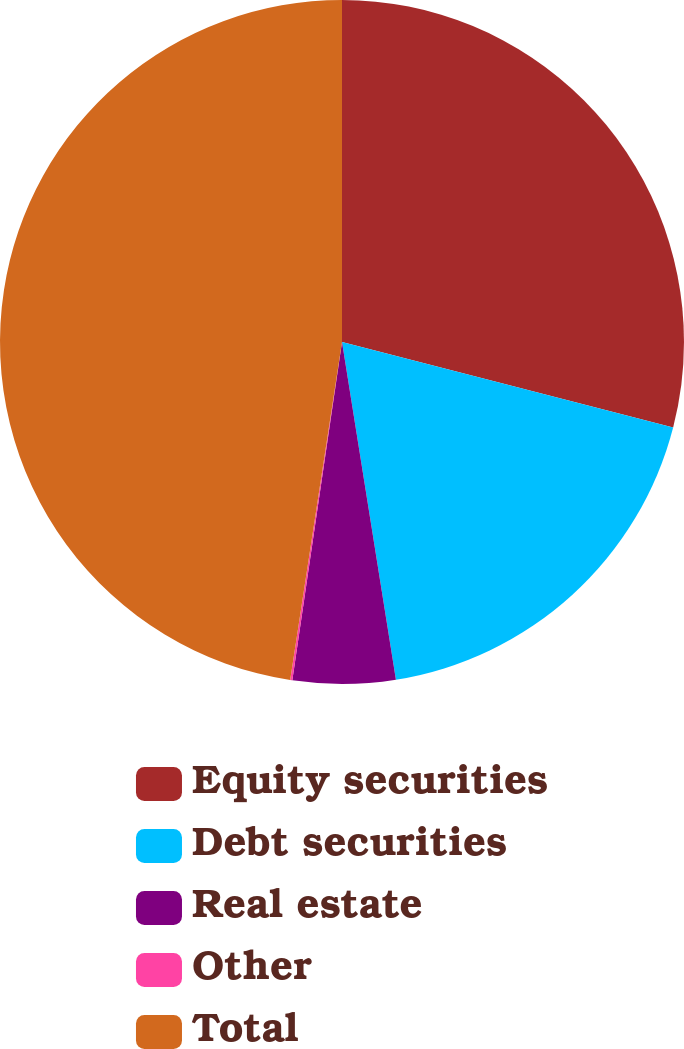Convert chart. <chart><loc_0><loc_0><loc_500><loc_500><pie_chart><fcel>Equity securities<fcel>Debt securities<fcel>Real estate<fcel>Other<fcel>Total<nl><fcel>29.02%<fcel>18.46%<fcel>4.84%<fcel>0.1%<fcel>47.58%<nl></chart> 